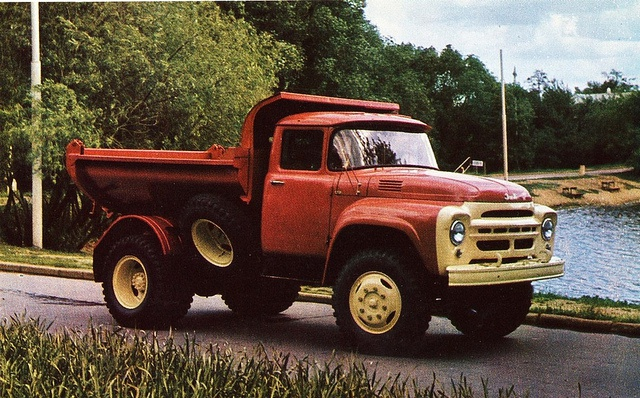Describe the objects in this image and their specific colors. I can see a truck in ivory, black, maroon, brown, and lightgray tones in this image. 